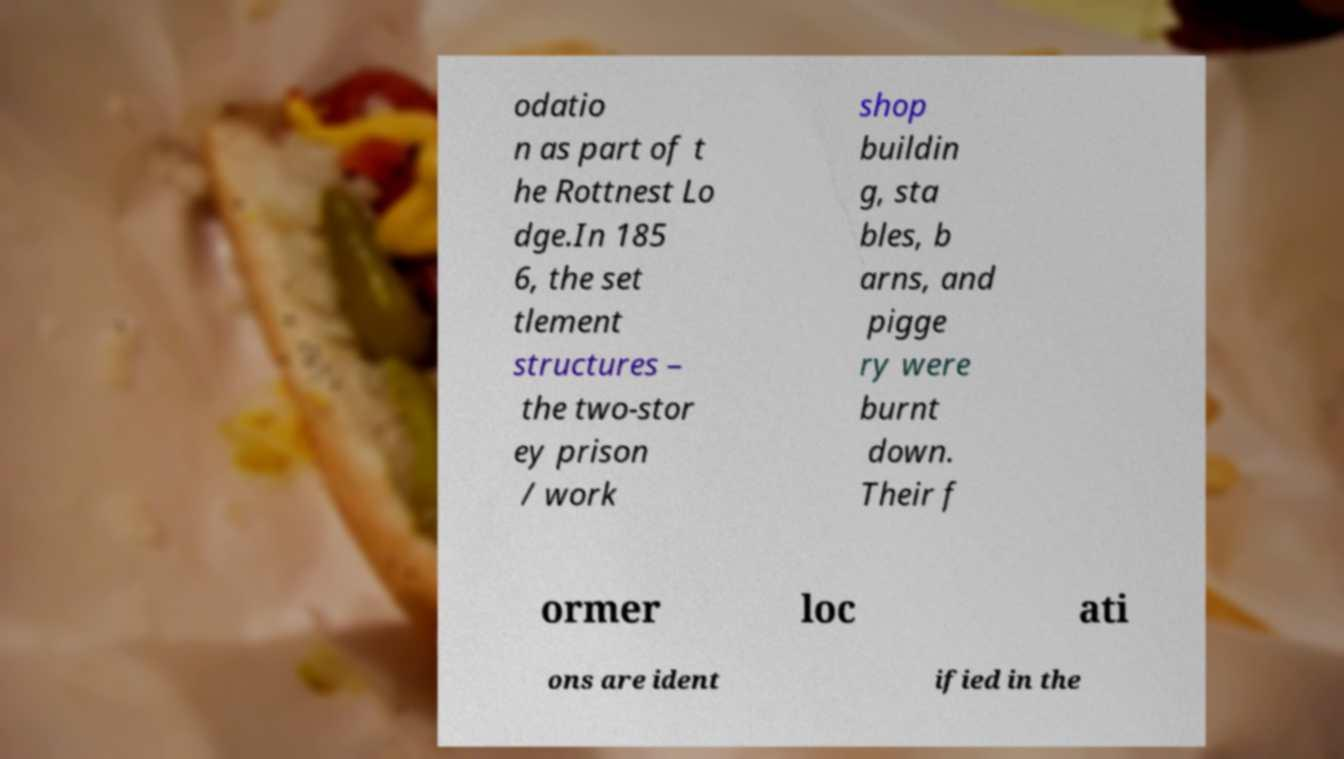I need the written content from this picture converted into text. Can you do that? odatio n as part of t he Rottnest Lo dge.In 185 6, the set tlement structures – the two-stor ey prison / work shop buildin g, sta bles, b arns, and pigge ry were burnt down. Their f ormer loc ati ons are ident ified in the 